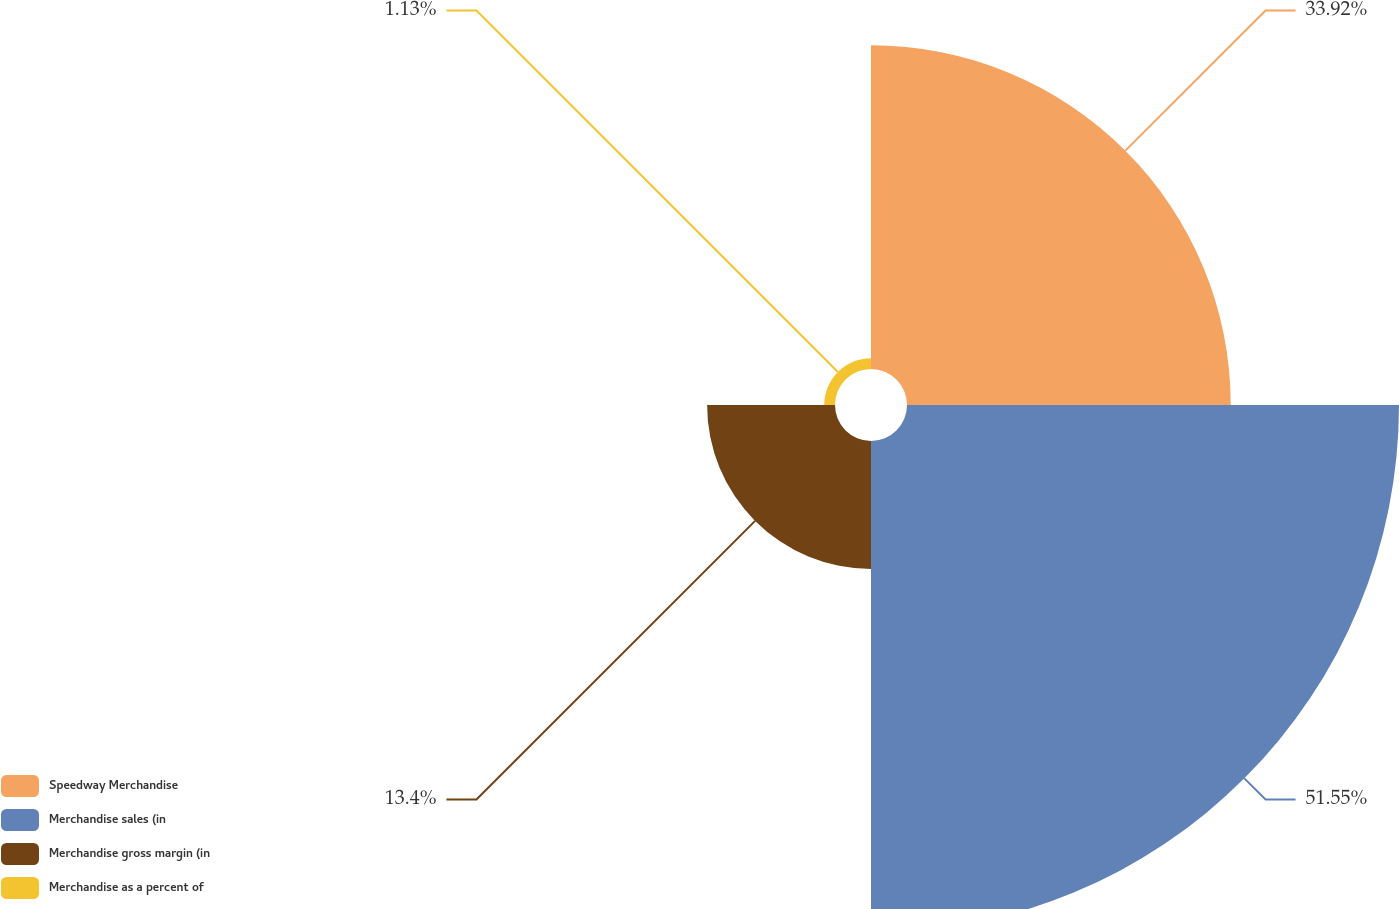Convert chart to OTSL. <chart><loc_0><loc_0><loc_500><loc_500><pie_chart><fcel>Speedway Merchandise<fcel>Merchandise sales (in<fcel>Merchandise gross margin (in<fcel>Merchandise as a percent of<nl><fcel>33.92%<fcel>51.55%<fcel>13.4%<fcel>1.13%<nl></chart> 